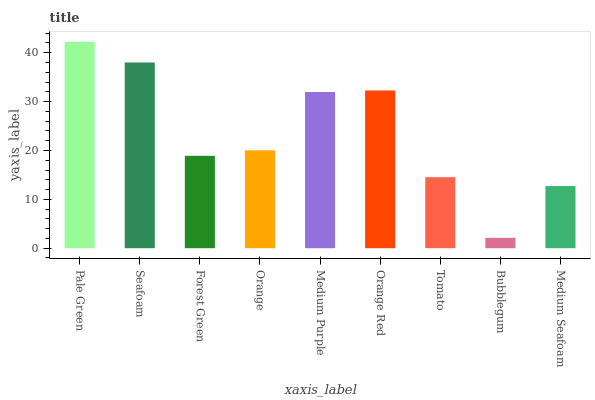Is Seafoam the minimum?
Answer yes or no. No. Is Seafoam the maximum?
Answer yes or no. No. Is Pale Green greater than Seafoam?
Answer yes or no. Yes. Is Seafoam less than Pale Green?
Answer yes or no. Yes. Is Seafoam greater than Pale Green?
Answer yes or no. No. Is Pale Green less than Seafoam?
Answer yes or no. No. Is Orange the high median?
Answer yes or no. Yes. Is Orange the low median?
Answer yes or no. Yes. Is Bubblegum the high median?
Answer yes or no. No. Is Forest Green the low median?
Answer yes or no. No. 